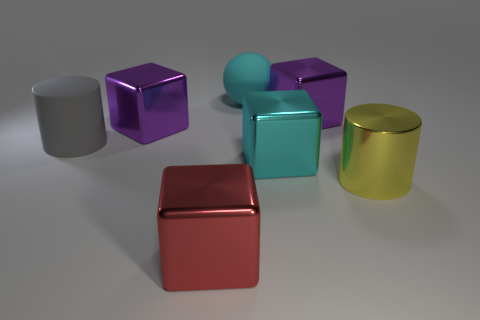There is a thing that is the same color as the big rubber sphere; what shape is it?
Offer a terse response. Cube. Do the big gray thing and the large cyan object that is behind the gray thing have the same material?
Ensure brevity in your answer.  Yes. There is another thing that is the same shape as the yellow metal thing; what is it made of?
Your response must be concise. Rubber. Does the large cyan block behind the red metal cube have the same material as the cylinder behind the large yellow object?
Your answer should be very brief. No. The large matte object that is in front of the purple shiny block that is right of the metallic thing in front of the big yellow cylinder is what color?
Your answer should be compact. Gray. What number of other objects are the same shape as the big cyan metal object?
Offer a terse response. 3. How many objects are either yellow metal cylinders or matte things on the left side of the big cyan matte ball?
Ensure brevity in your answer.  2. Is there a red block of the same size as the cyan ball?
Provide a short and direct response. Yes. Is the material of the yellow cylinder the same as the red block?
Keep it short and to the point. Yes. How many objects are purple shiny cubes or large yellow shiny things?
Offer a terse response. 3. 